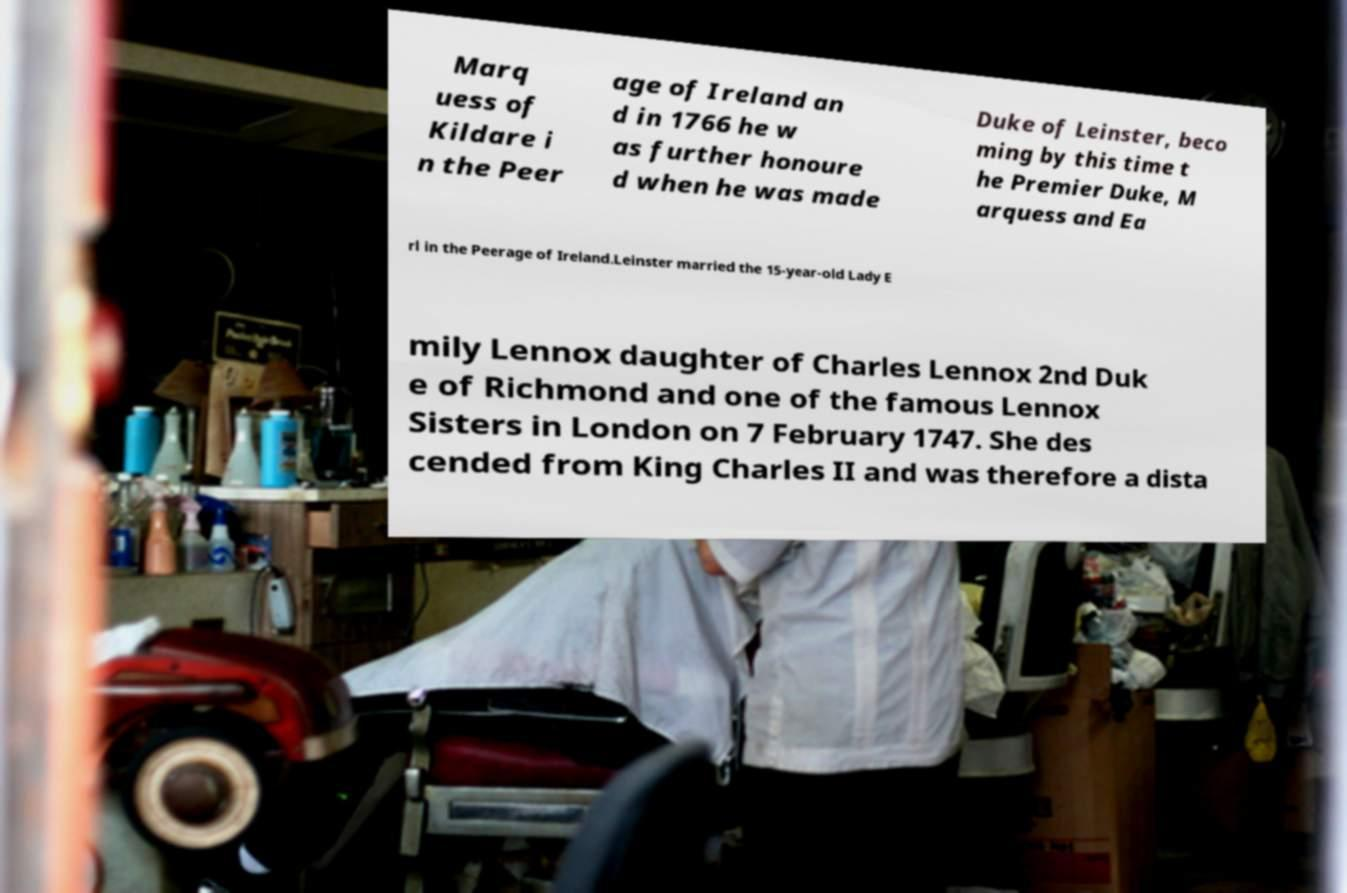What messages or text are displayed in this image? I need them in a readable, typed format. Marq uess of Kildare i n the Peer age of Ireland an d in 1766 he w as further honoure d when he was made Duke of Leinster, beco ming by this time t he Premier Duke, M arquess and Ea rl in the Peerage of Ireland.Leinster married the 15-year-old Lady E mily Lennox daughter of Charles Lennox 2nd Duk e of Richmond and one of the famous Lennox Sisters in London on 7 February 1747. She des cended from King Charles II and was therefore a dista 